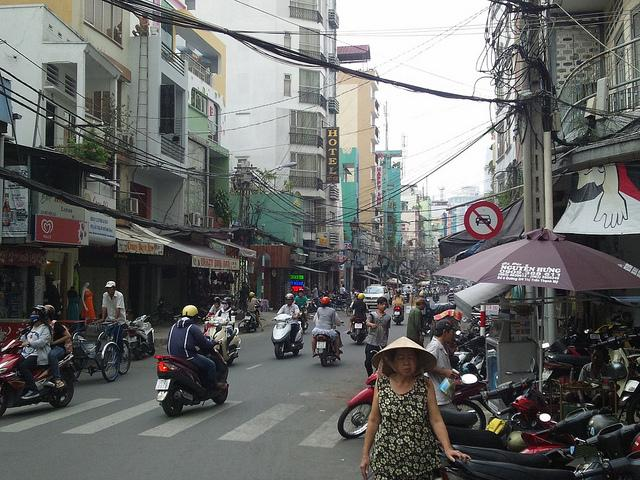Why is the woman wearing a triangular hat? protection 